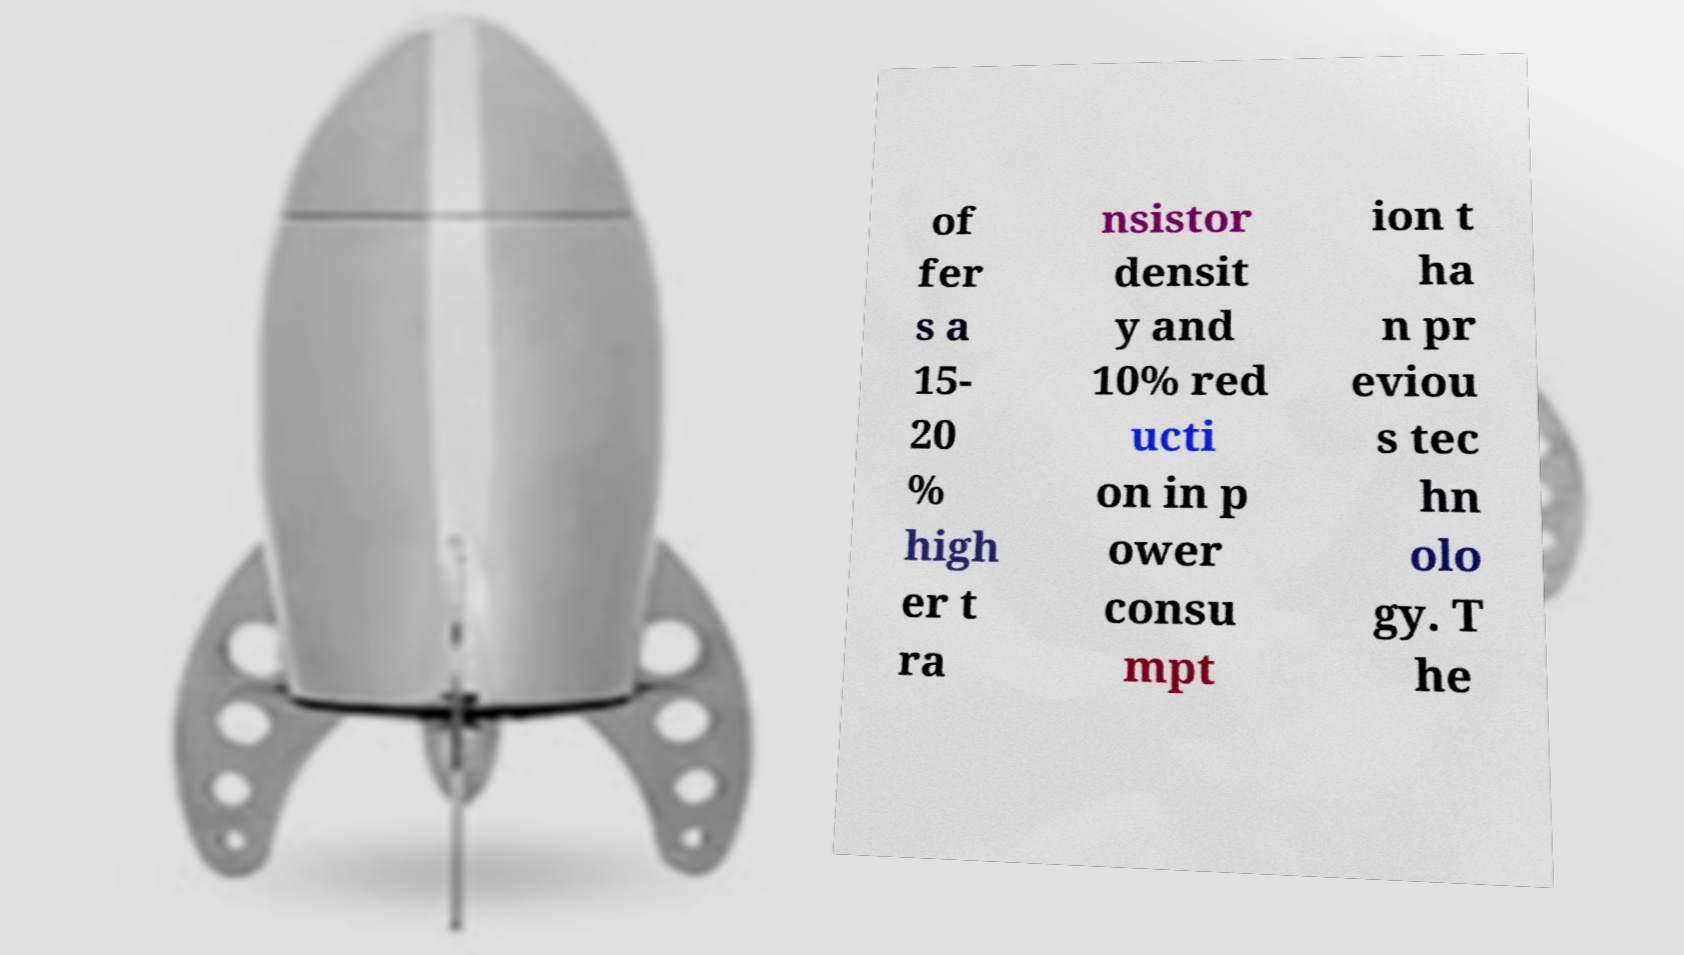Please identify and transcribe the text found in this image. of fer s a 15- 20 % high er t ra nsistor densit y and 10% red ucti on in p ower consu mpt ion t ha n pr eviou s tec hn olo gy. T he 